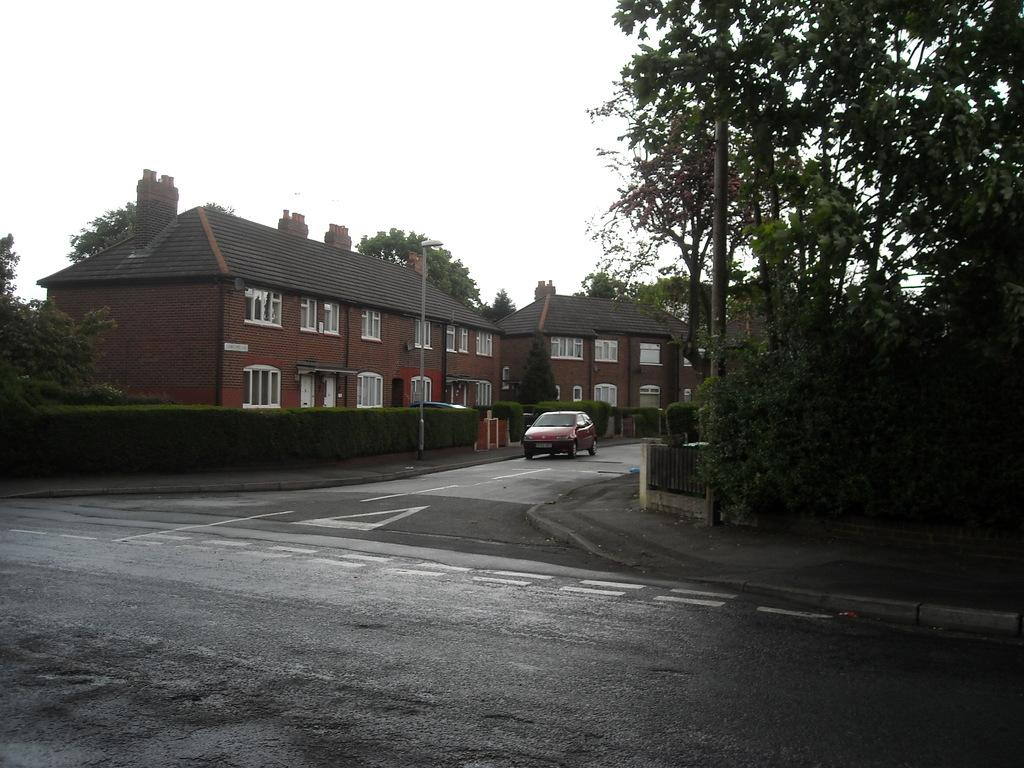How many buildings can be seen in the image? There are two buildings in the image. What is the primary feature of the image? The primary feature of the image is a road. What can be seen in the background of the image? There is sky visible in the image, along with many trees and plants. Are there any structures along the road in the image? Yes, there are two street poles in the image. What arithmetic problem can be solved using the numbers on the street poles in the image? There is no arithmetic problem present in the image, as the street poles do not have any numbers on them. What rule is being followed by the trees in the image? There is no rule being followed by the trees in the image; they are simply growing naturally. 